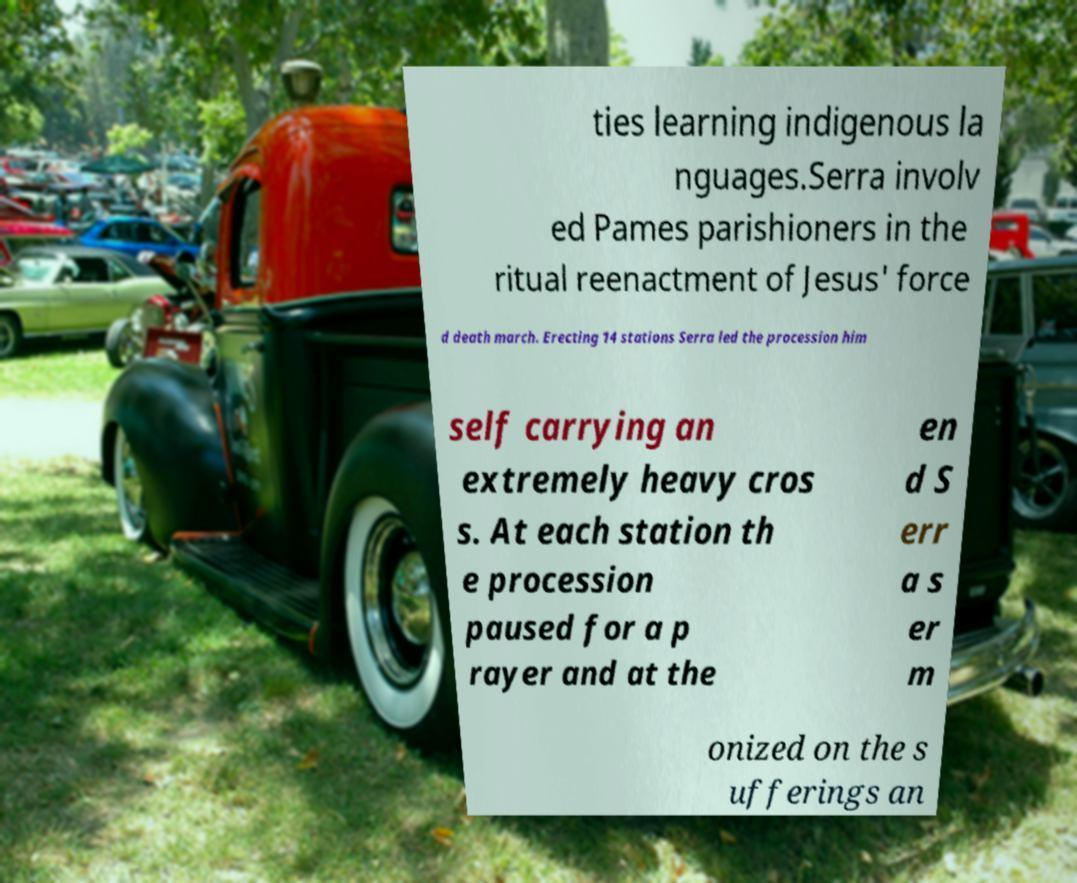Please read and relay the text visible in this image. What does it say? ties learning indigenous la nguages.Serra involv ed Pames parishioners in the ritual reenactment of Jesus' force d death march. Erecting 14 stations Serra led the procession him self carrying an extremely heavy cros s. At each station th e procession paused for a p rayer and at the en d S err a s er m onized on the s ufferings an 